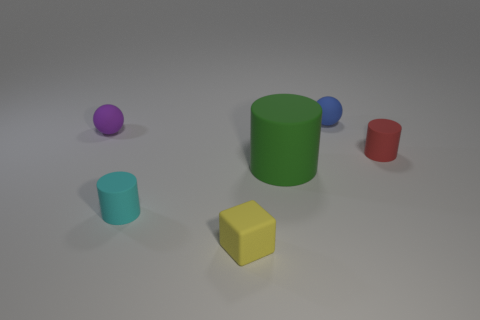Is there anything else that has the same size as the green matte cylinder?
Your answer should be compact. No. There is a tiny cylinder left of the red matte cylinder; what is its color?
Your answer should be very brief. Cyan. What number of things are spheres behind the tiny purple matte thing or small purple spheres?
Your answer should be very brief. 2. What is the color of the rubber block that is the same size as the blue sphere?
Give a very brief answer. Yellow. Are there more small red things that are to the right of the blue sphere than tiny spheres?
Your response must be concise. No. The tiny thing that is both to the left of the big green object and behind the red rubber object is made of what material?
Offer a terse response. Rubber. There is a tiny matte sphere that is left of the yellow rubber block; does it have the same color as the small cylinder that is behind the big matte object?
Ensure brevity in your answer.  No. What number of other things are the same size as the blue matte thing?
Provide a short and direct response. 4. Are there any rubber things that are to the left of the tiny cylinder that is on the left side of the tiny rubber cylinder behind the large green cylinder?
Give a very brief answer. Yes. Is the material of the tiny cylinder that is on the left side of the red thing the same as the blue thing?
Your response must be concise. Yes. 